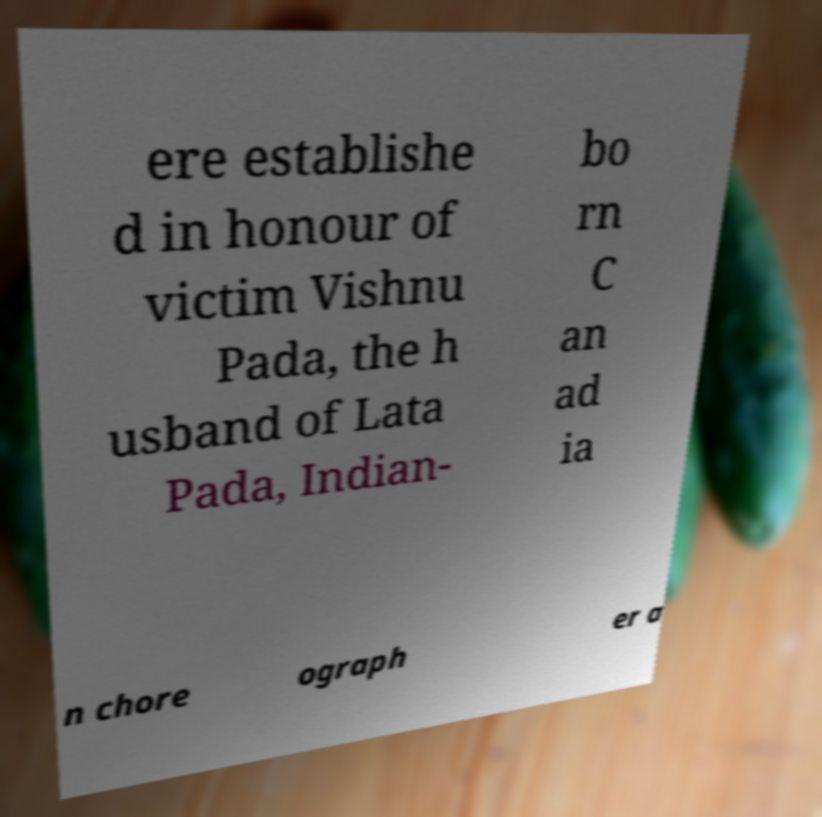Please read and relay the text visible in this image. What does it say? ere establishe d in honour of victim Vishnu Pada, the h usband of Lata Pada, Indian- bo rn C an ad ia n chore ograph er a 